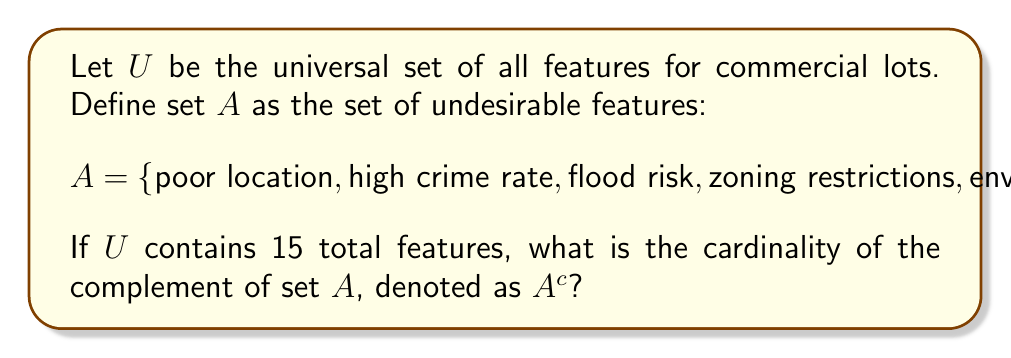Show me your answer to this math problem. To solve this problem, we need to understand the concept of complement sets and use the given information:

1) The universal set $U$ contains all possible features for commercial lots. We're told that $|U| = 15$, meaning there are 15 total features.

2) Set $A$ contains the undesirable features, and we're given 5 elements in this set. Therefore, $|A| = 5$.

3) The complement of set $A$, denoted as $A^c$, contains all elements in the universal set $U$ that are not in $A$. In other words, $A^c$ represents all features that are not undesirable.

4) We can use the following formula to find the cardinality of the complement:

   $|A^c| = |U| - |A|$

5) Substituting the known values:

   $|A^c| = 15 - 5 = 10$

Therefore, there are 10 features in the complement set $A^c$, which represents the desirable or neutral features for commercial lots.
Answer: $|A^c| = 10$ 